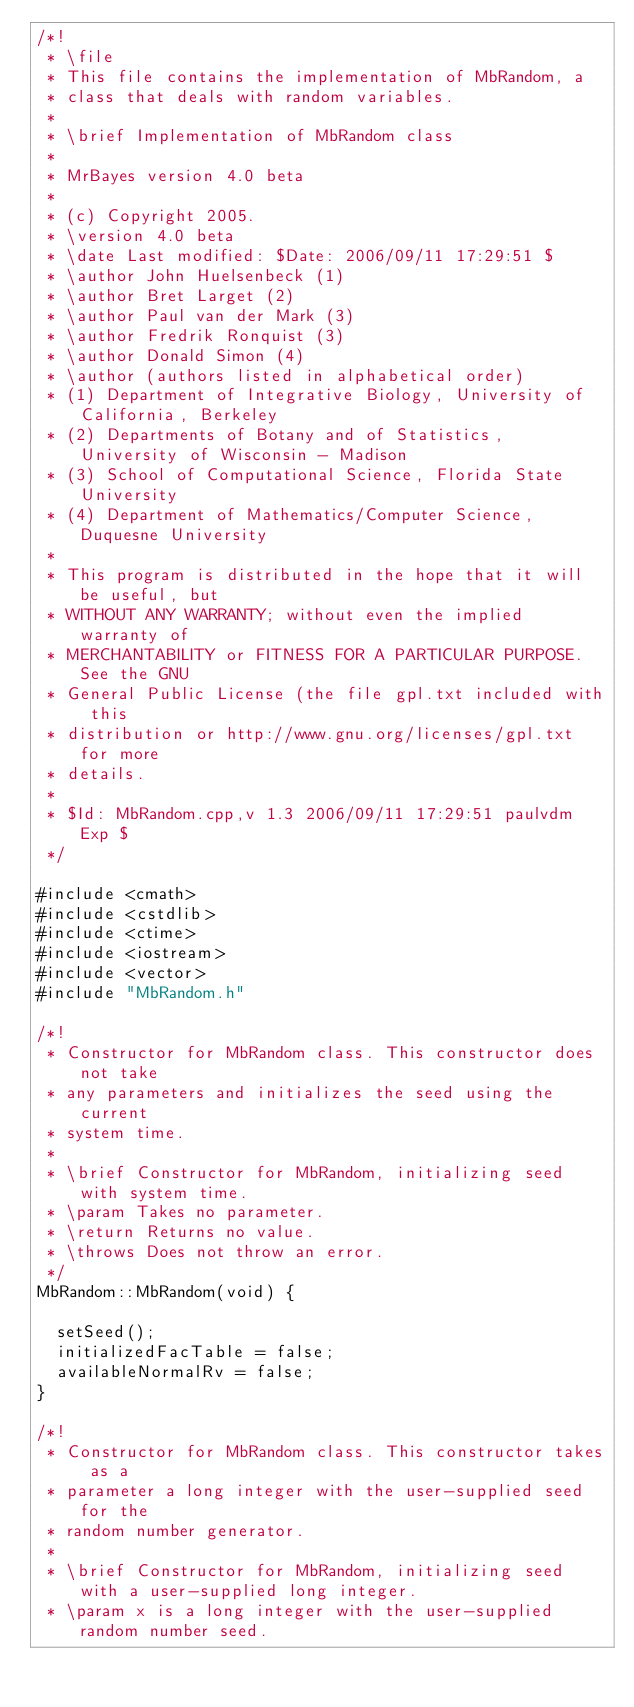Convert code to text. <code><loc_0><loc_0><loc_500><loc_500><_C++_>/*! 
 * \file
 * This file contains the implementation of MbRandom, a
 * class that deals with random variables. 
 *
 * \brief Implementation of MbRandom class 
 *
 * MrBayes version 4.0 beta
 *
 * (c) Copyright 2005.
 * \version 4.0 beta
 * \date Last modified: $Date: 2006/09/11 17:29:51 $
 * \author John Huelsenbeck (1)
 * \author Bret Larget (2)
 * \author Paul van der Mark (3)
 * \author Fredrik Ronquist (3)
 * \author Donald Simon (4)
 * \author (authors listed in alphabetical order)
 * (1) Department of Integrative Biology, University of California, Berkeley
 * (2) Departments of Botany and of Statistics, University of Wisconsin - Madison
 * (3) School of Computational Science, Florida State University
 * (4) Department of Mathematics/Computer Science, Duquesne University
 *
 * This program is distributed in the hope that it will be useful, but
 * WITHOUT ANY WARRANTY; without even the implied warranty of
 * MERCHANTABILITY or FITNESS FOR A PARTICULAR PURPOSE.  See the GNU
 * General Public License (the file gpl.txt included with this
 * distribution or http://www.gnu.org/licenses/gpl.txt for more
 * details.
 *
 * $Id: MbRandom.cpp,v 1.3 2006/09/11 17:29:51 paulvdm Exp $
 */

#include <cmath>
#include <cstdlib>
#include <ctime>
#include <iostream>
#include <vector>
#include "MbRandom.h"

/*!
 * Constructor for MbRandom class. This constructor does not take
 * any parameters and initializes the seed using the current 
 * system time.
 *
 * \brief Constructor for MbRandom, initializing seed with system time.
 * \param Takes no parameter.
 * \return Returns no value.
 * \throws Does not throw an error.
 */
MbRandom::MbRandom(void) {

	setSeed();
	initializedFacTable = false;
	availableNormalRv = false;
}

/*!
 * Constructor for MbRandom class. This constructor takes as a
 * parameter a long integer with the user-supplied seed for the
 * random number generator. 
 *
 * \brief Constructor for MbRandom, initializing seed with a user-supplied long integer.
 * \param x is a long integer with the user-supplied random number seed.</code> 